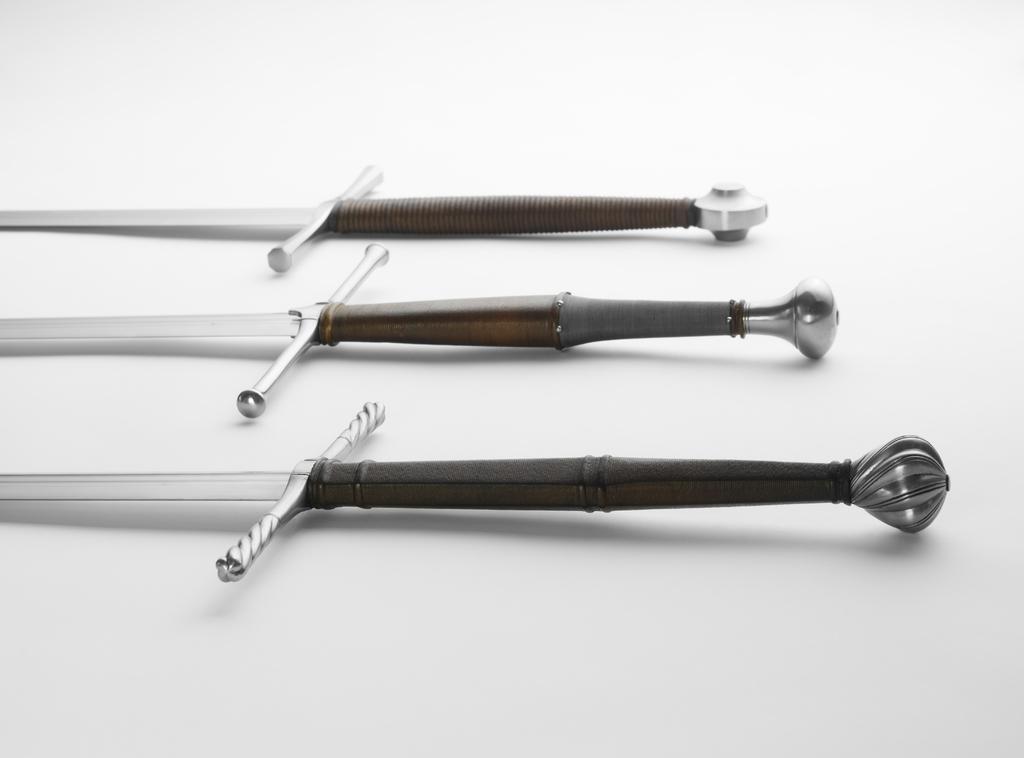How would you summarize this image in a sentence or two? In this image I can see few weapons in white, brown and black color. They are on the white color surface. 